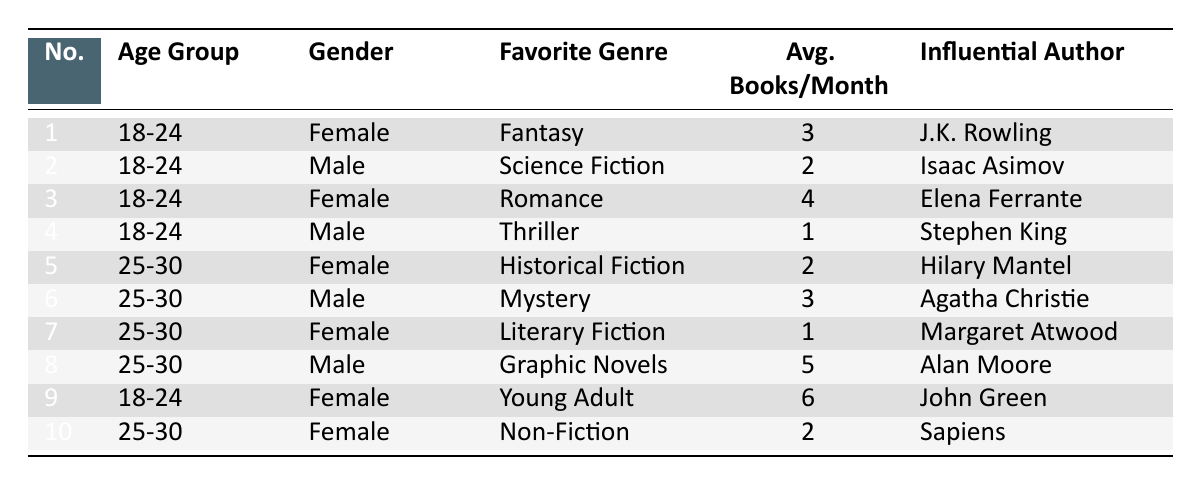What is the favorite genre of the youngest female readers? From the table, we can find the rows corresponding to the age group "18-24" and gender "Female." The favorite genres listed are Fantasy, Romance, and Young Adult.
Answer: Fantasy, Romance, Young Adult Which influential author is associated with the favorite genre of Mystery? To answer this, locate the row for the genre "Mystery." The corresponding influential author for that genre is Agatha Christie, as identified in the table.
Answer: Agatha Christie What is the average number of books read per month by male readers aged 25-30? We need to sum up the average books read by male readers in the age group 25-30. They are 3 (Mystery) and 5 (Graphic Novels). Adding them gives 3 + 5 = 8. There are 2 data points for this group, so we find the average by dividing 8 by 2, which equals 4.
Answer: 4 Do any female readers aged 18-24 prefer Thriller as their favorite genre? Checking the table, the genres for female readers aged 18-24 include Fantasy, Romance, and Young Adult, but none of them prefer Thriller. Therefore, the statement is false.
Answer: No Which age group has the highest reader count for the genre of Young Adult? The table shows that only one entry corresponds to the genre Young Adult, specified under the age group 18-24 for females. Thus, there is only one data point for Young Adult.
Answer: 18-24 What is the most popular genre among male readers aged 25-30 based on the average books read per month? The two male genres for the age group 25-30 are Mystery (average 3 books) and Graphic Novels (average 5 books). Comparing them, Graphic Novels have the highest average.
Answer: Graphic Novels How many average books do female readers read per month across all genres? We sum the average books read for all female entries: 3 (Fantasy) + 4 (Romance) + 2 (Historical Fiction) + 1 (Literary Fiction) + 6 (Young Adult) + 2 (Non-Fiction) = 18. There are 6 female readers, so the average is 18 divided by 6, which equals 3.
Answer: 3 Are there more female readers than male readers in the age group 18-24? The table indicates there are four female readers (Fantasy, Romance, Young Adult) and two male readers (Science Fiction, Thriller) in the age group 18-24. Thus, there are more females.
Answer: Yes 